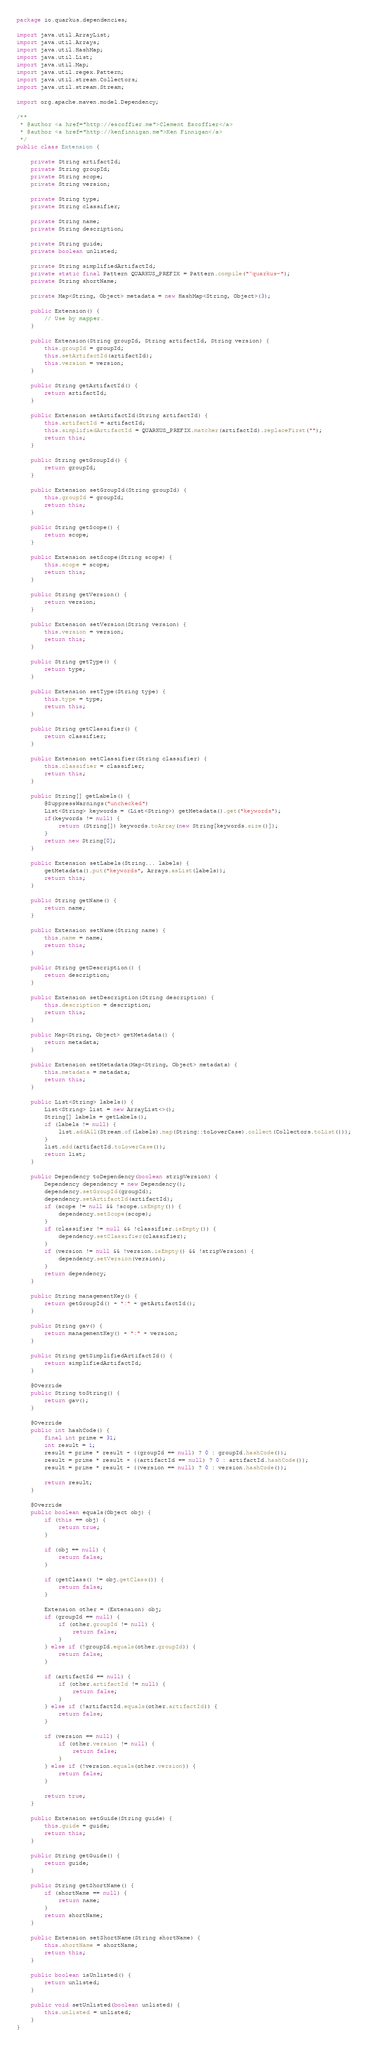<code> <loc_0><loc_0><loc_500><loc_500><_Java_>package io.quarkus.dependencies;

import java.util.ArrayList;
import java.util.Arrays;
import java.util.HashMap;
import java.util.List;
import java.util.Map;
import java.util.regex.Pattern;
import java.util.stream.Collectors;
import java.util.stream.Stream;

import org.apache.maven.model.Dependency;

/**
 * @author <a href="http://escoffier.me">Clement Escoffier</a>
 * @author <a href="http://kenfinnigan.me">Ken Finnigan</a>
 */
public class Extension {

    private String artifactId;
    private String groupId;
    private String scope;
    private String version;

    private String type;
    private String classifier;

    private String name;
    private String description;

    private String guide;
    private boolean unlisted;

    private String simplifiedArtifactId;
    private static final Pattern QUARKUS_PREFIX = Pattern.compile("^quarkus-");
    private String shortName;

    private Map<String, Object> metadata = new HashMap<String, Object>(3);

    public Extension() {
        // Use by mapper.
    }

    public Extension(String groupId, String artifactId, String version) {
        this.groupId = groupId;
        this.setArtifactId(artifactId);
        this.version = version;
    }

    public String getArtifactId() {
        return artifactId;
    }

    public Extension setArtifactId(String artifactId) {
        this.artifactId = artifactId;
        this.simplifiedArtifactId = QUARKUS_PREFIX.matcher(artifactId).replaceFirst("");
        return this;
    }

    public String getGroupId() {
        return groupId;
    }

    public Extension setGroupId(String groupId) {
        this.groupId = groupId;
        return this;
    }

    public String getScope() {
        return scope;
    }

    public Extension setScope(String scope) {
        this.scope = scope;
        return this;
    }

    public String getVersion() {
        return version;
    }

    public Extension setVersion(String version) {
        this.version = version;
        return this;
    }

    public String getType() {
        return type;
    }

    public Extension setType(String type) {
        this.type = type;
        return this;
    }

    public String getClassifier() {
        return classifier;
    }

    public Extension setClassifier(String classifier) {
        this.classifier = classifier;
        return this;
    }

    public String[] getLabels() {
    	@SuppressWarnings("unchecked")
        List<String> keywords = (List<String>) getMetadata().get("keywords");
    	if(keywords != null) {
    		return (String[]) keywords.toArray(new String[keywords.size()]);
    	}
        return new String[0];
    }

    public Extension setLabels(String... labels) {
        getMetadata().put("keywords", Arrays.asList(labels));
        return this;
    }

    public String getName() {
        return name;
    }

    public Extension setName(String name) {
        this.name = name;
        return this;
    }

    public String getDescription() {
        return description;
    }

    public Extension setDescription(String description) {
        this.description = description;
        return this;
    }

    public Map<String, Object> getMetadata() {
    	return metadata;
    }

    public Extension setMetadata(Map<String, Object> metadata) {
    	this.metadata = metadata;
    	return this;
    }

    public List<String> labels() {
        List<String> list = new ArrayList<>();
        String[] labels = getLabels();
        if (labels != null) {
            list.addAll(Stream.of(labels).map(String::toLowerCase).collect(Collectors.toList()));
        }
        list.add(artifactId.toLowerCase());
        return list;
    }

    public Dependency toDependency(boolean stripVersion) {
        Dependency dependency = new Dependency();
        dependency.setGroupId(groupId);
        dependency.setArtifactId(artifactId);
        if (scope != null && !scope.isEmpty()) {
            dependency.setScope(scope);
        }
        if (classifier != null && !classifier.isEmpty()) {
            dependency.setClassifier(classifier);
        }
        if (version != null && !version.isEmpty() && !stripVersion) {
            dependency.setVersion(version);
        }
        return dependency;
    }

    public String managementKey() {
        return getGroupId() + ":" + getArtifactId();
    }

    public String gav() {
        return managementKey() + ":" + version;
    }

    public String getSimplifiedArtifactId() {
        return simplifiedArtifactId;
    }

    @Override
    public String toString() {
        return gav();
    }

    @Override
    public int hashCode() {
        final int prime = 31;
        int result = 1;
        result = prime * result + ((groupId == null) ? 0 : groupId.hashCode());
        result = prime * result + ((artifactId == null) ? 0 : artifactId.hashCode());
        result = prime * result + ((version == null) ? 0 : version.hashCode());

        return result;
    }

    @Override
    public boolean equals(Object obj) {
        if (this == obj) {
            return true;
        }

        if (obj == null) {
            return false;
        }

        if (getClass() != obj.getClass()) {
            return false;
        }

        Extension other = (Extension) obj;
        if (groupId == null) {
            if (other.groupId != null) {
                return false;
            }
        } else if (!groupId.equals(other.groupId)) {
            return false;
        }

        if (artifactId == null) {
            if (other.artifactId != null) {
                return false;
            }
        } else if (!artifactId.equals(other.artifactId)) {
            return false;
        }

        if (version == null) {
            if (other.version != null) {
                return false;
            }
        } else if (!version.equals(other.version)) {
            return false;
        }

        return true;
    }

    public Extension setGuide(String guide) {
    	this.guide = guide;
    	return this;
    }

    public String getGuide() {
        return guide;
    }

    public String getShortName() {
        if (shortName == null) {
            return name;
        }
        return shortName;
    }

    public Extension setShortName(String shortName) {
        this.shortName = shortName;
        return this;
    }

	public boolean isUnlisted() {
		return unlisted;
	}

	public void setUnlisted(boolean unlisted) {
		this.unlisted = unlisted;
	}
}
</code> 